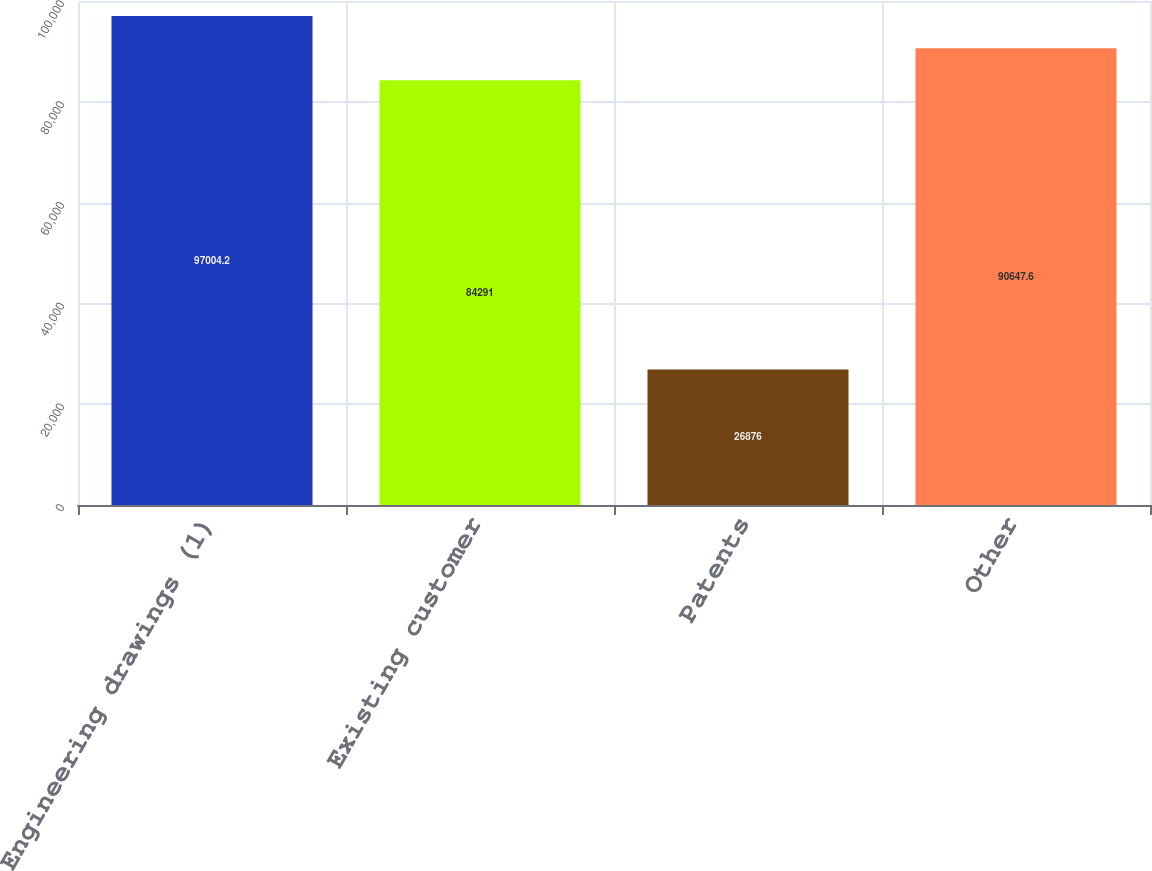<chart> <loc_0><loc_0><loc_500><loc_500><bar_chart><fcel>Engineering drawings (1)<fcel>Existing customer<fcel>Patents<fcel>Other<nl><fcel>97004.2<fcel>84291<fcel>26876<fcel>90647.6<nl></chart> 